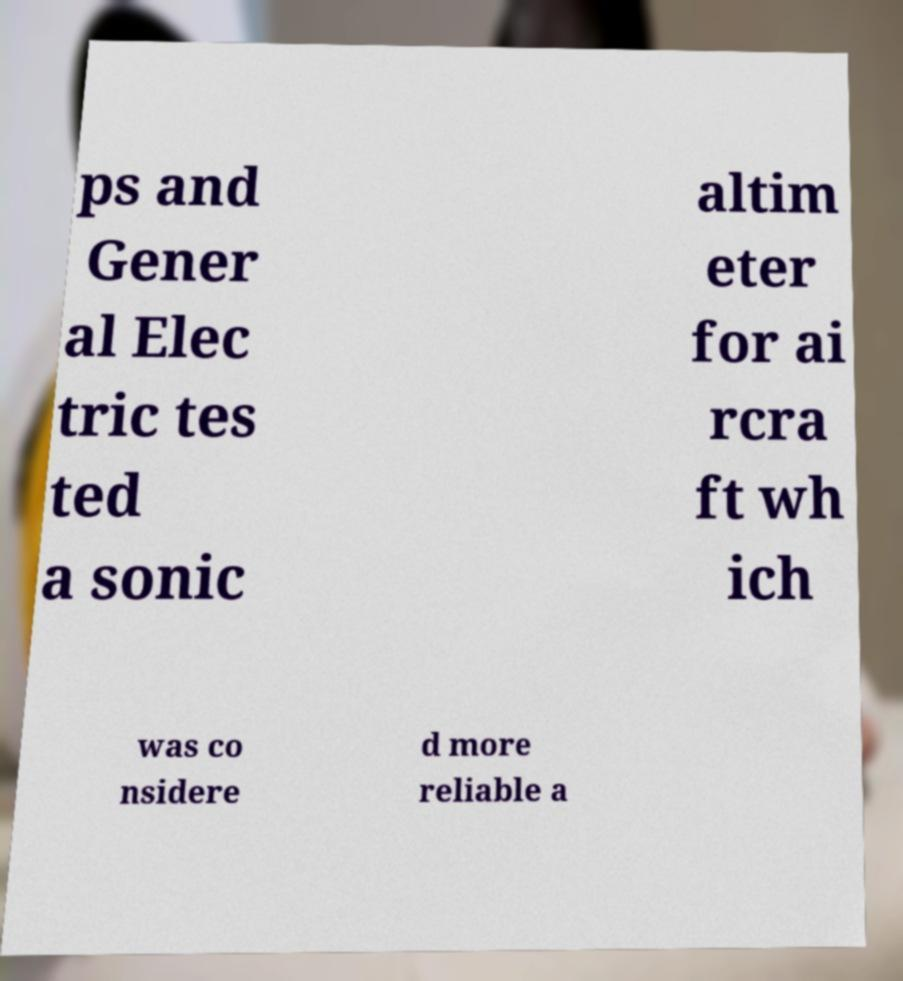Please identify and transcribe the text found in this image. ps and Gener al Elec tric tes ted a sonic altim eter for ai rcra ft wh ich was co nsidere d more reliable a 